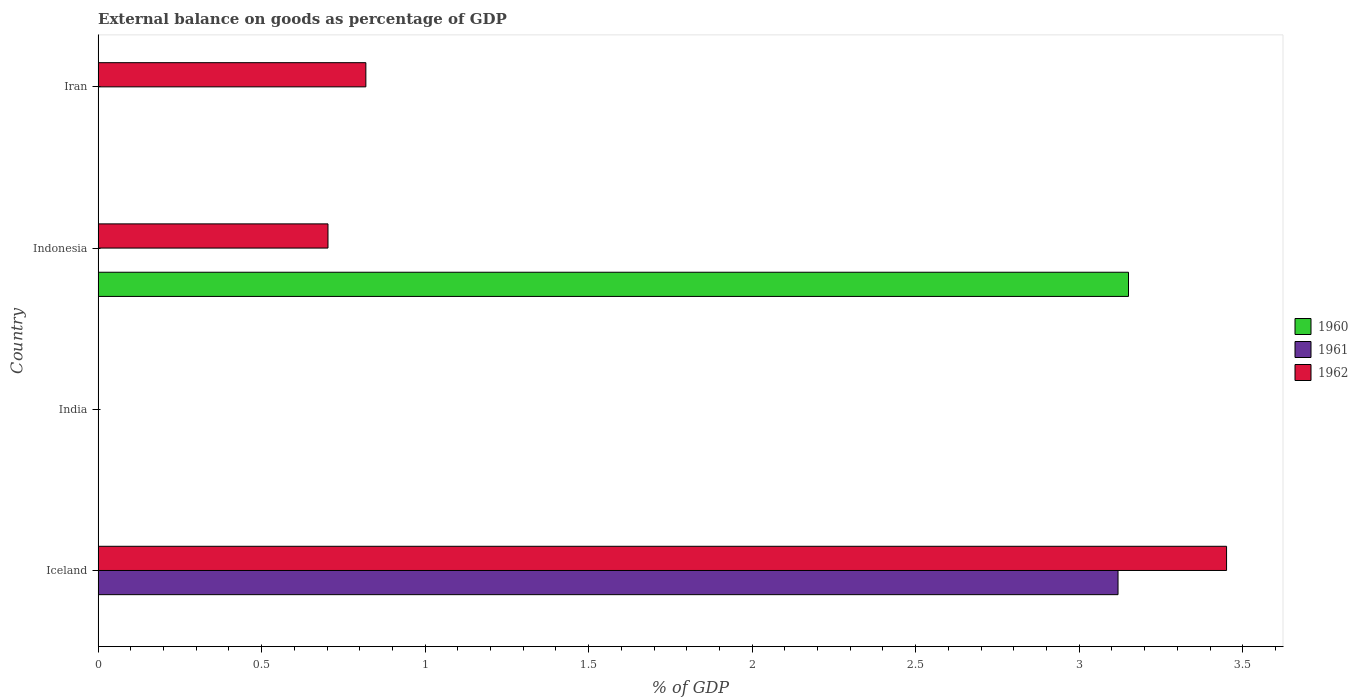How many different coloured bars are there?
Your answer should be compact. 3. Are the number of bars per tick equal to the number of legend labels?
Your answer should be compact. No. What is the label of the 1st group of bars from the top?
Offer a very short reply. Iran. Across all countries, what is the maximum external balance on goods as percentage of GDP in 1962?
Your answer should be compact. 3.45. In which country was the external balance on goods as percentage of GDP in 1962 maximum?
Offer a very short reply. Iceland. What is the total external balance on goods as percentage of GDP in 1960 in the graph?
Your response must be concise. 3.15. What is the difference between the external balance on goods as percentage of GDP in 1962 in Indonesia and that in Iran?
Provide a short and direct response. -0.12. What is the difference between the external balance on goods as percentage of GDP in 1962 in India and the external balance on goods as percentage of GDP in 1961 in Indonesia?
Keep it short and to the point. 0. What is the average external balance on goods as percentage of GDP in 1961 per country?
Your response must be concise. 0.78. What is the difference between the external balance on goods as percentage of GDP in 1960 and external balance on goods as percentage of GDP in 1962 in Indonesia?
Keep it short and to the point. 2.45. What is the difference between the highest and the second highest external balance on goods as percentage of GDP in 1962?
Keep it short and to the point. 2.63. What is the difference between the highest and the lowest external balance on goods as percentage of GDP in 1962?
Provide a short and direct response. 3.45. Is the sum of the external balance on goods as percentage of GDP in 1962 in Iceland and Iran greater than the maximum external balance on goods as percentage of GDP in 1961 across all countries?
Give a very brief answer. Yes. How many bars are there?
Ensure brevity in your answer.  5. Are all the bars in the graph horizontal?
Provide a short and direct response. Yes. How many countries are there in the graph?
Provide a succinct answer. 4. What is the difference between two consecutive major ticks on the X-axis?
Your response must be concise. 0.5. Does the graph contain any zero values?
Offer a very short reply. Yes. Where does the legend appear in the graph?
Provide a succinct answer. Center right. How are the legend labels stacked?
Your answer should be very brief. Vertical. What is the title of the graph?
Ensure brevity in your answer.  External balance on goods as percentage of GDP. What is the label or title of the X-axis?
Your response must be concise. % of GDP. What is the % of GDP in 1961 in Iceland?
Your answer should be very brief. 3.12. What is the % of GDP in 1962 in Iceland?
Provide a succinct answer. 3.45. What is the % of GDP of 1960 in India?
Make the answer very short. 0. What is the % of GDP in 1961 in India?
Give a very brief answer. 0. What is the % of GDP in 1960 in Indonesia?
Your answer should be compact. 3.15. What is the % of GDP in 1962 in Indonesia?
Provide a short and direct response. 0.7. What is the % of GDP in 1960 in Iran?
Offer a terse response. 0. What is the % of GDP of 1961 in Iran?
Make the answer very short. 0. What is the % of GDP in 1962 in Iran?
Offer a very short reply. 0.82. Across all countries, what is the maximum % of GDP of 1960?
Make the answer very short. 3.15. Across all countries, what is the maximum % of GDP of 1961?
Offer a very short reply. 3.12. Across all countries, what is the maximum % of GDP in 1962?
Offer a terse response. 3.45. Across all countries, what is the minimum % of GDP of 1960?
Keep it short and to the point. 0. Across all countries, what is the minimum % of GDP of 1961?
Give a very brief answer. 0. Across all countries, what is the minimum % of GDP of 1962?
Keep it short and to the point. 0. What is the total % of GDP of 1960 in the graph?
Ensure brevity in your answer.  3.15. What is the total % of GDP in 1961 in the graph?
Ensure brevity in your answer.  3.12. What is the total % of GDP of 1962 in the graph?
Ensure brevity in your answer.  4.97. What is the difference between the % of GDP of 1962 in Iceland and that in Indonesia?
Make the answer very short. 2.75. What is the difference between the % of GDP of 1962 in Iceland and that in Iran?
Provide a short and direct response. 2.63. What is the difference between the % of GDP in 1962 in Indonesia and that in Iran?
Keep it short and to the point. -0.12. What is the difference between the % of GDP of 1961 in Iceland and the % of GDP of 1962 in Indonesia?
Ensure brevity in your answer.  2.42. What is the difference between the % of GDP of 1961 in Iceland and the % of GDP of 1962 in Iran?
Your response must be concise. 2.3. What is the difference between the % of GDP in 1960 in Indonesia and the % of GDP in 1962 in Iran?
Give a very brief answer. 2.33. What is the average % of GDP in 1960 per country?
Provide a short and direct response. 0.79. What is the average % of GDP in 1961 per country?
Your response must be concise. 0.78. What is the average % of GDP in 1962 per country?
Offer a very short reply. 1.24. What is the difference between the % of GDP in 1961 and % of GDP in 1962 in Iceland?
Provide a succinct answer. -0.33. What is the difference between the % of GDP in 1960 and % of GDP in 1962 in Indonesia?
Offer a terse response. 2.45. What is the ratio of the % of GDP in 1962 in Iceland to that in Indonesia?
Keep it short and to the point. 4.91. What is the ratio of the % of GDP of 1962 in Iceland to that in Iran?
Provide a short and direct response. 4.21. What is the ratio of the % of GDP in 1962 in Indonesia to that in Iran?
Your answer should be compact. 0.86. What is the difference between the highest and the second highest % of GDP of 1962?
Your response must be concise. 2.63. What is the difference between the highest and the lowest % of GDP in 1960?
Ensure brevity in your answer.  3.15. What is the difference between the highest and the lowest % of GDP of 1961?
Offer a terse response. 3.12. What is the difference between the highest and the lowest % of GDP in 1962?
Your response must be concise. 3.45. 